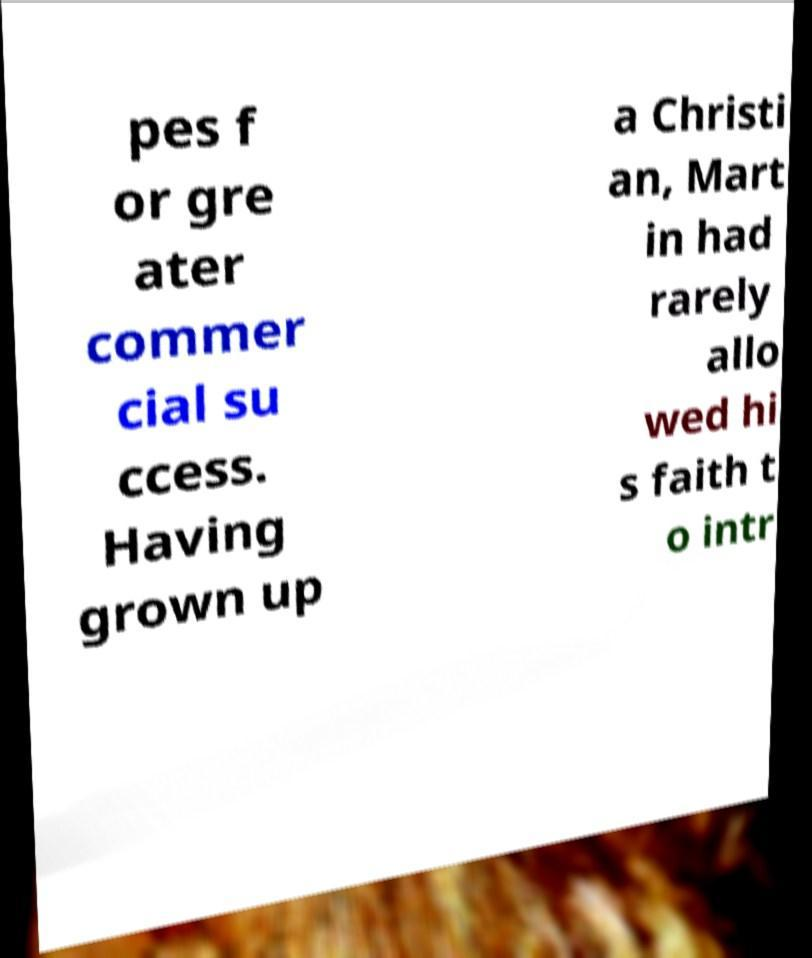There's text embedded in this image that I need extracted. Can you transcribe it verbatim? pes f or gre ater commer cial su ccess. Having grown up a Christi an, Mart in had rarely allo wed hi s faith t o intr 